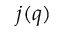<formula> <loc_0><loc_0><loc_500><loc_500>j ( q )</formula> 